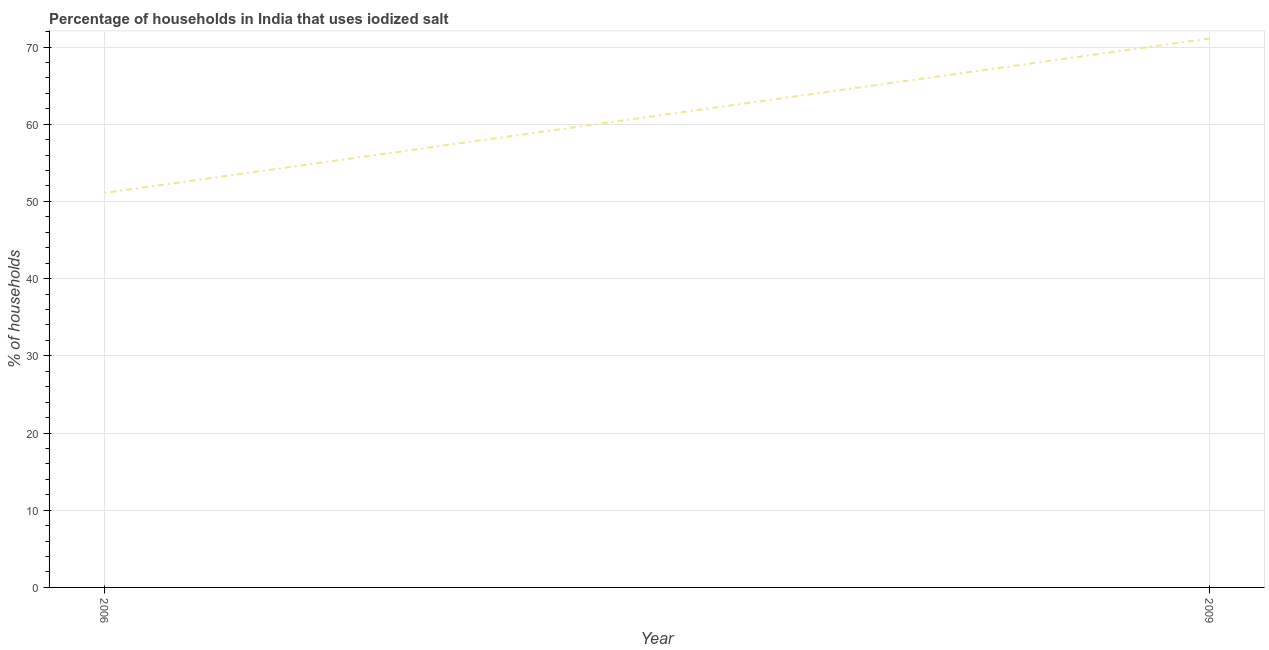What is the percentage of households where iodized salt is consumed in 2006?
Ensure brevity in your answer.  51.1. Across all years, what is the maximum percentage of households where iodized salt is consumed?
Provide a short and direct response. 71.1. Across all years, what is the minimum percentage of households where iodized salt is consumed?
Make the answer very short. 51.1. What is the sum of the percentage of households where iodized salt is consumed?
Offer a very short reply. 122.2. What is the difference between the percentage of households where iodized salt is consumed in 2006 and 2009?
Your answer should be compact. -20. What is the average percentage of households where iodized salt is consumed per year?
Provide a short and direct response. 61.1. What is the median percentage of households where iodized salt is consumed?
Your answer should be very brief. 61.1. Do a majority of the years between 2009 and 2006 (inclusive) have percentage of households where iodized salt is consumed greater than 58 %?
Your answer should be compact. No. What is the ratio of the percentage of households where iodized salt is consumed in 2006 to that in 2009?
Your response must be concise. 0.72. Is the percentage of households where iodized salt is consumed in 2006 less than that in 2009?
Ensure brevity in your answer.  Yes. In how many years, is the percentage of households where iodized salt is consumed greater than the average percentage of households where iodized salt is consumed taken over all years?
Offer a terse response. 1. Does the percentage of households where iodized salt is consumed monotonically increase over the years?
Make the answer very short. Yes. How many years are there in the graph?
Offer a terse response. 2. What is the difference between two consecutive major ticks on the Y-axis?
Keep it short and to the point. 10. Are the values on the major ticks of Y-axis written in scientific E-notation?
Offer a terse response. No. What is the title of the graph?
Offer a very short reply. Percentage of households in India that uses iodized salt. What is the label or title of the Y-axis?
Your answer should be compact. % of households. What is the % of households of 2006?
Your response must be concise. 51.1. What is the % of households in 2009?
Your answer should be compact. 71.1. What is the difference between the % of households in 2006 and 2009?
Keep it short and to the point. -20. What is the ratio of the % of households in 2006 to that in 2009?
Offer a terse response. 0.72. 